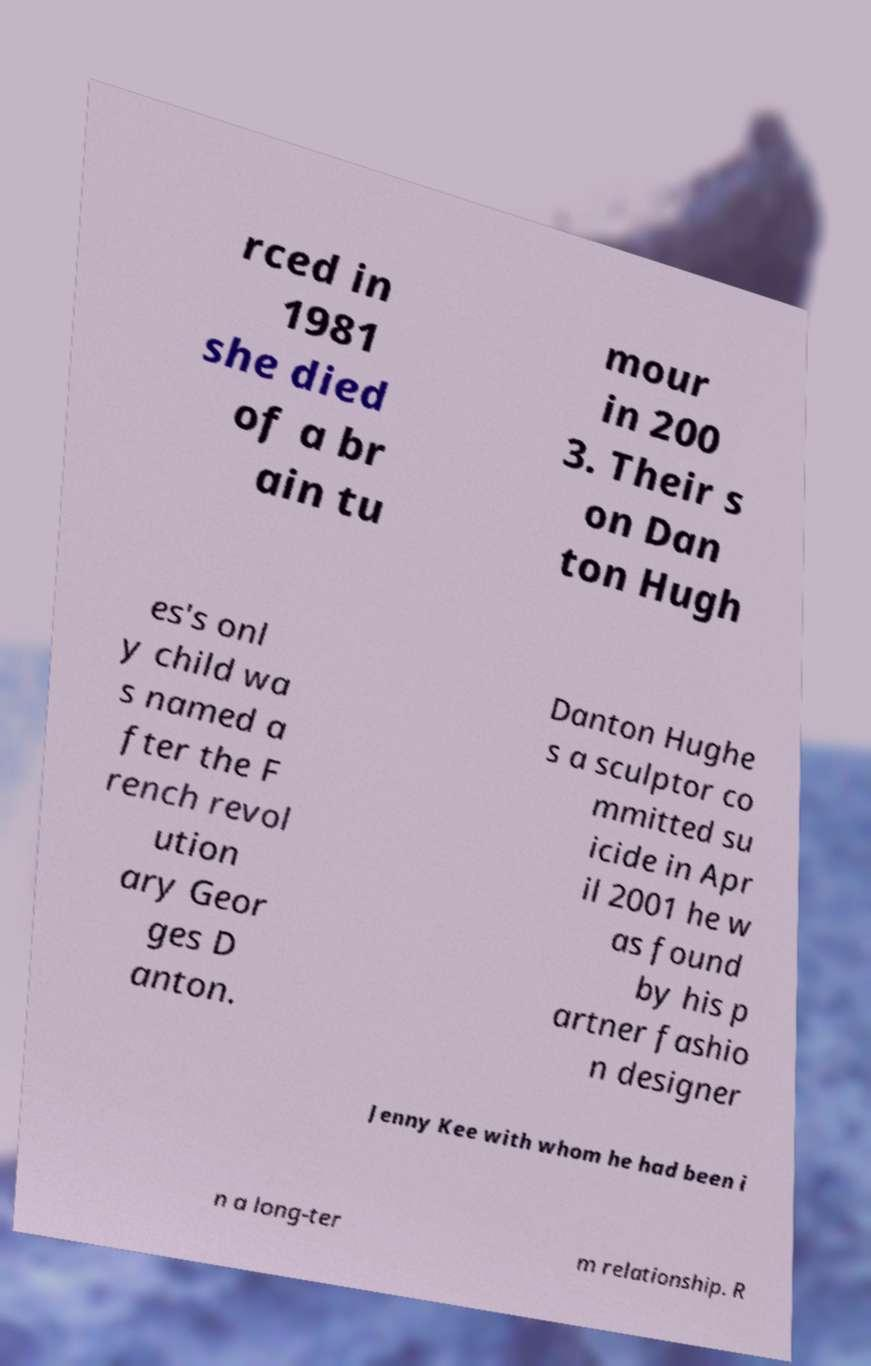Could you assist in decoding the text presented in this image and type it out clearly? rced in 1981 she died of a br ain tu mour in 200 3. Their s on Dan ton Hugh es's onl y child wa s named a fter the F rench revol ution ary Geor ges D anton. Danton Hughe s a sculptor co mmitted su icide in Apr il 2001 he w as found by his p artner fashio n designer Jenny Kee with whom he had been i n a long-ter m relationship. R 